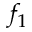Convert formula to latex. <formula><loc_0><loc_0><loc_500><loc_500>f _ { 1 }</formula> 